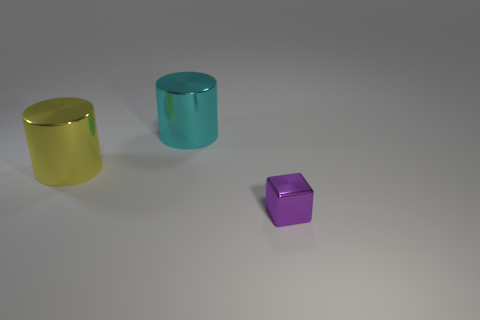Add 1 cyan cylinders. How many objects exist? 4 Subtract all cylinders. How many objects are left? 1 Subtract 0 purple spheres. How many objects are left? 3 Subtract 1 cylinders. How many cylinders are left? 1 Subtract all blue blocks. Subtract all red balls. How many blocks are left? 1 Subtract all big yellow spheres. Subtract all tiny purple cubes. How many objects are left? 2 Add 1 yellow cylinders. How many yellow cylinders are left? 2 Add 3 cylinders. How many cylinders exist? 5 